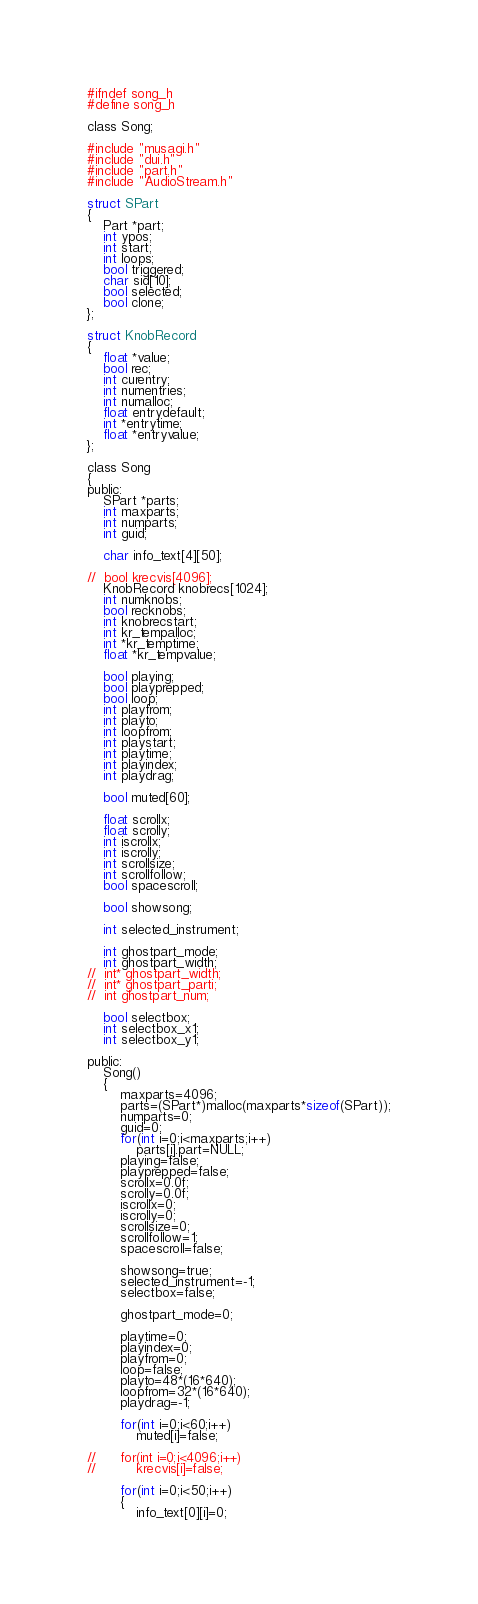<code> <loc_0><loc_0><loc_500><loc_500><_C_>#ifndef song_h
#define song_h

class Song;

#include "musagi.h"
#include "dui.h"
#include "part.h"
#include "AudioStream.h"

struct SPart
{
	Part *part;
	int ypos;
	int start;
	int loops;
	bool triggered;
	char sid[10];
	bool selected;
	bool clone;
};

struct KnobRecord
{
	float *value;
	bool rec;
	int curentry;
	int numentries;
	int numalloc;
	float entrydefault;
	int *entrytime;
	float *entryvalue;
};

class Song
{
public:
	SPart *parts;
	int maxparts;
	int numparts;
	int guid;

	char info_text[4][50];

//	bool krecvis[4096];
	KnobRecord knobrecs[1024];
	int numknobs;
	bool recknobs;
	int knobrecstart;
	int kr_tempalloc;
	int *kr_temptime;
	float *kr_tempvalue;
	
	bool playing;
	bool playprepped;
	bool loop;
	int playfrom;
	int playto;
	int loopfrom;
	int playstart;
	int playtime;
	int playindex;
	int playdrag;
	
	bool muted[60];
	
	float scrollx;
	float scrolly;
	int iscrollx;
	int iscrolly;
	int scrollsize;
	int scrollfollow;
	bool spacescroll;
	
	bool showsong;
	
	int selected_instrument;
	
	int ghostpart_mode;
	int ghostpart_width;
//	int* ghostpart_width;
//	int* ghostpart_parti;
//	int ghostpart_num;
	
	bool selectbox;
	int selectbox_x1;
	int selectbox_y1;
	
public:
	Song()
	{
		maxparts=4096;
		parts=(SPart*)malloc(maxparts*sizeof(SPart));
		numparts=0;
		guid=0;
		for(int i=0;i<maxparts;i++)
			parts[i].part=NULL;
		playing=false;
		playprepped=false;
		scrollx=0.0f;
		scrolly=0.0f;
		iscrollx=0;
		iscrolly=0;
		scrollsize=0;
		scrollfollow=1;
		spacescroll=false;

		showsong=true;
		selected_instrument=-1;
		selectbox=false;
		
		ghostpart_mode=0;
		
		playtime=0;
		playindex=0;
		playfrom=0;
		loop=false;
		playto=48*(16*640);
		loopfrom=32*(16*640);
		playdrag=-1;

		for(int i=0;i<60;i++)
			muted[i]=false;
		
//		for(int i=0;i<4096;i++)
//			krecvis[i]=false;
		
		for(int i=0;i<50;i++)
		{
			info_text[0][i]=0;</code> 